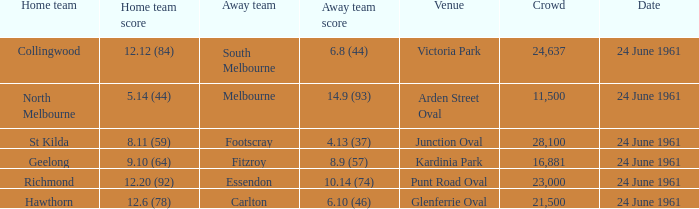10 (64) in the game? 24 June 1961. 